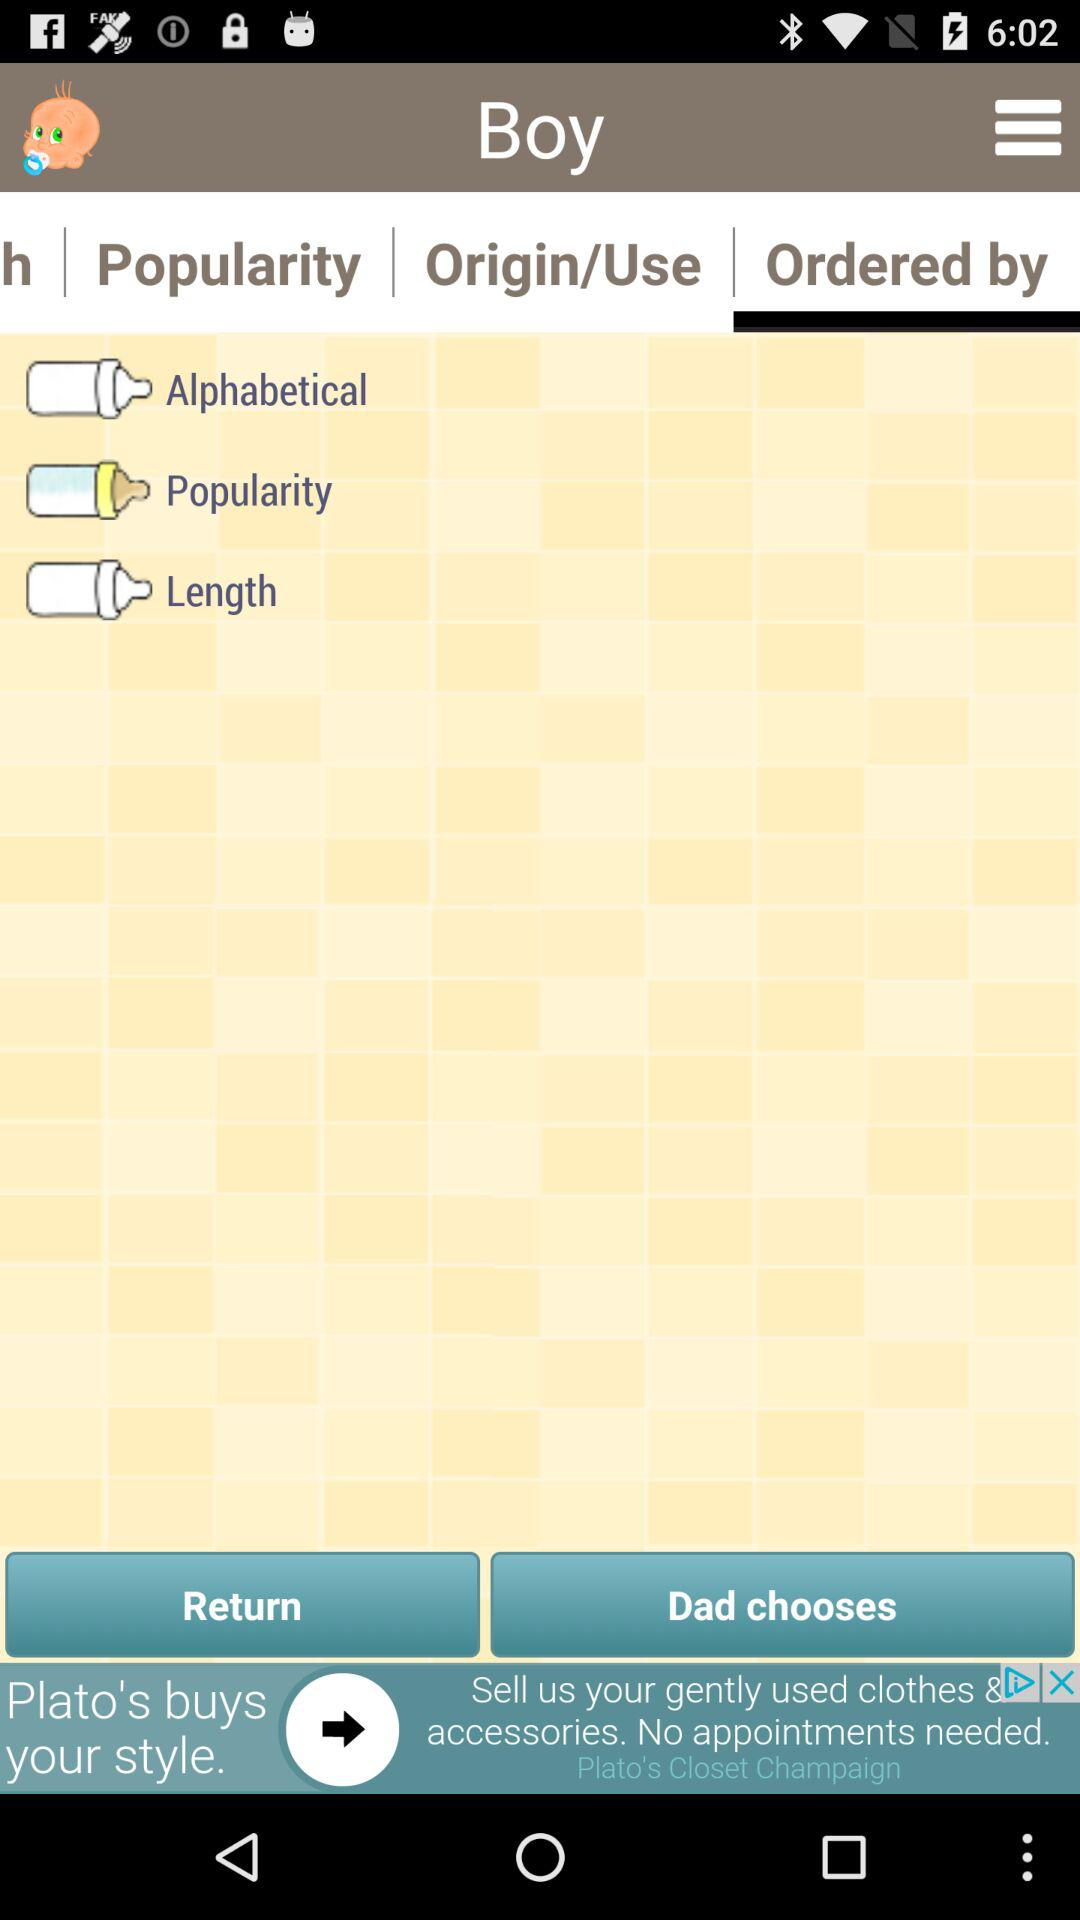Which tab is selected? The selected tab is "Ordered by". 